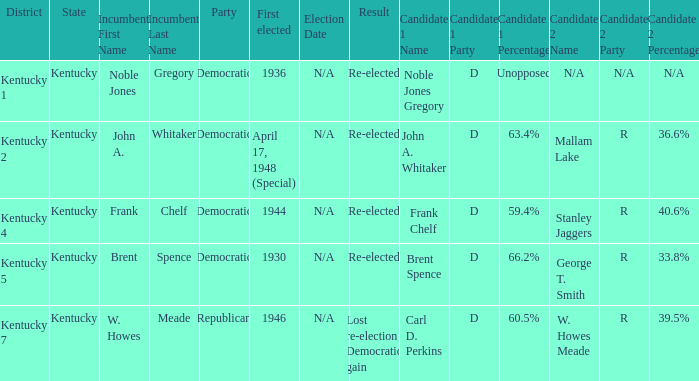What was the result in the voting district Kentucky 2? Re-elected. 